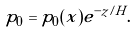Convert formula to latex. <formula><loc_0><loc_0><loc_500><loc_500>p _ { 0 } = p _ { 0 } ( x ) e ^ { - z / H } .</formula> 